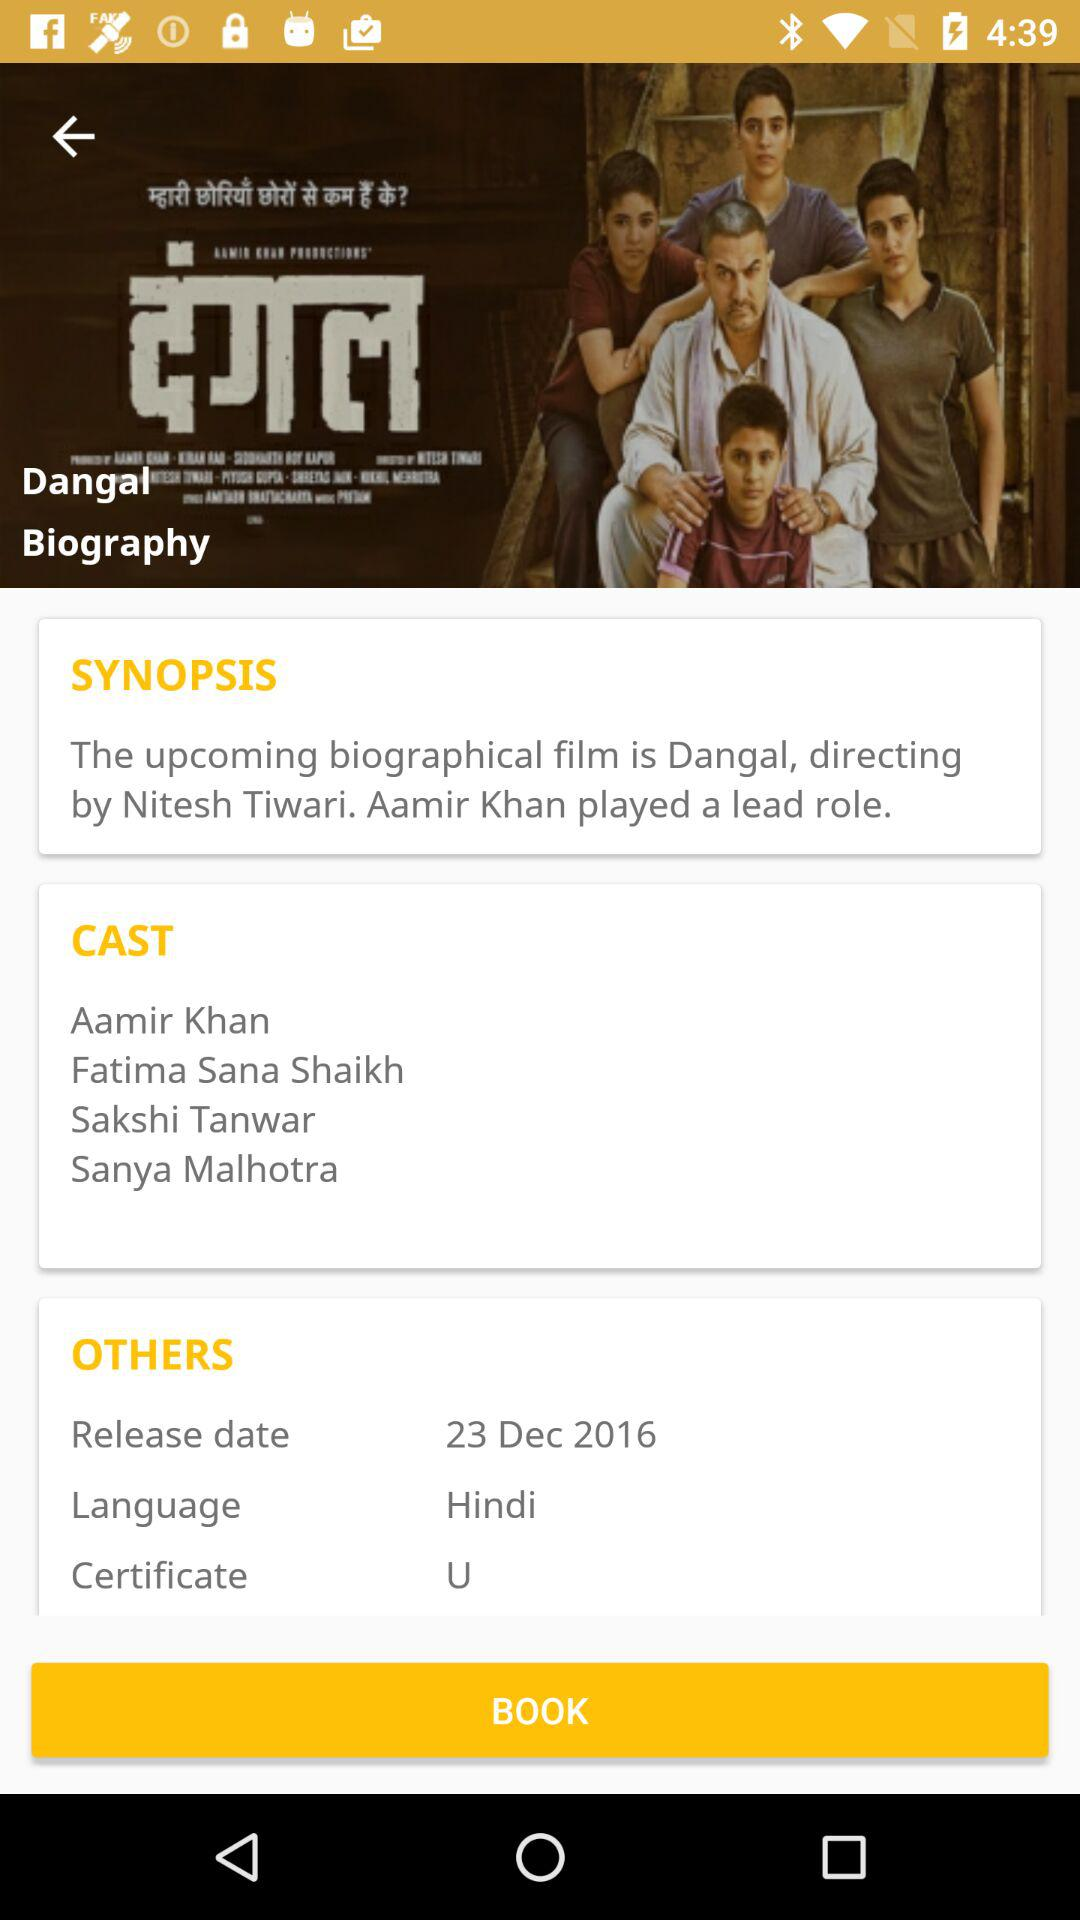What is the name of the movie? The name of the movie is "Dangal". 